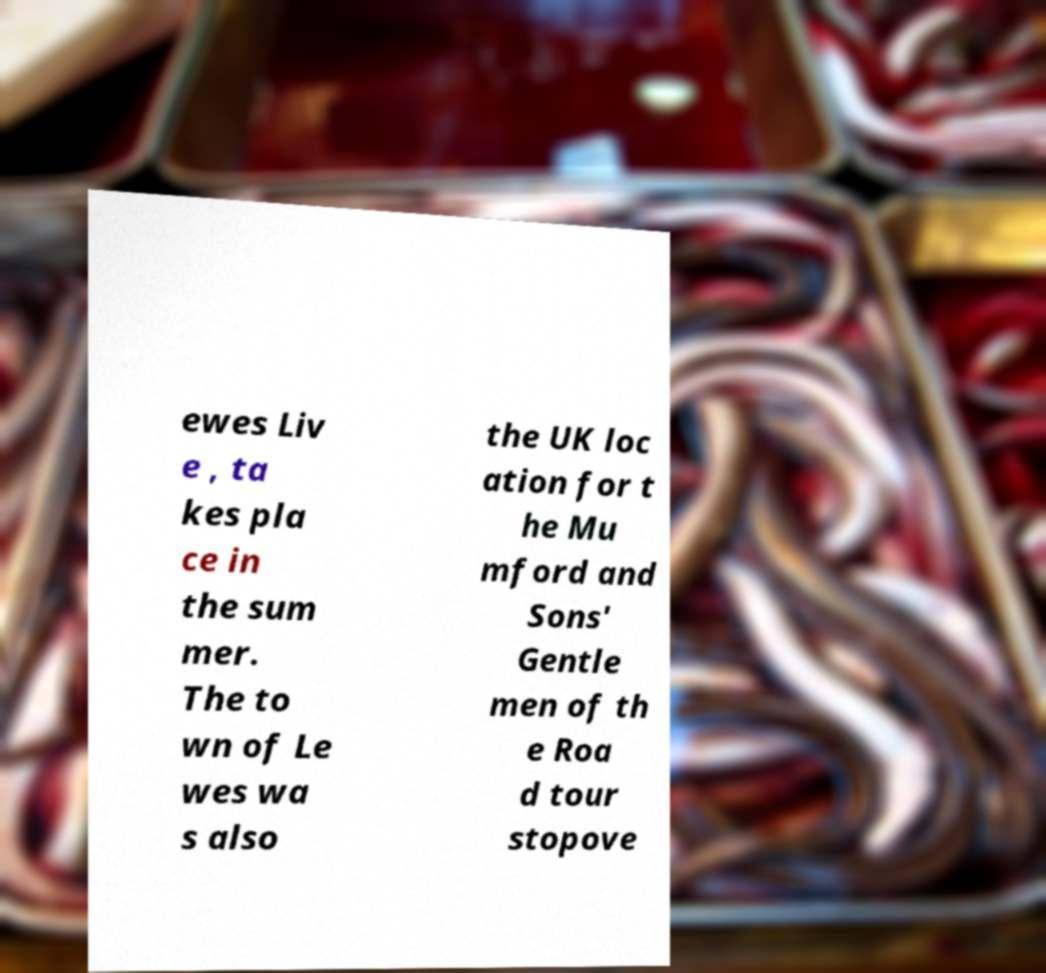Could you assist in decoding the text presented in this image and type it out clearly? ewes Liv e , ta kes pla ce in the sum mer. The to wn of Le wes wa s also the UK loc ation for t he Mu mford and Sons' Gentle men of th e Roa d tour stopove 